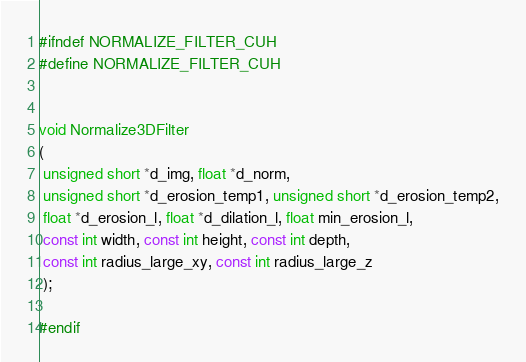<code> <loc_0><loc_0><loc_500><loc_500><_Cuda_>#ifndef NORMALIZE_FILTER_CUH
#define NORMALIZE_FILTER_CUH


void Normalize3DFilter
(
 unsigned short *d_img, float *d_norm,
 unsigned short *d_erosion_temp1, unsigned short *d_erosion_temp2,
 float *d_erosion_l, float *d_dilation_l, float min_erosion_l,
 const int width, const int height, const int depth,
 const int radius_large_xy, const int radius_large_z
 );

#endif
</code> 